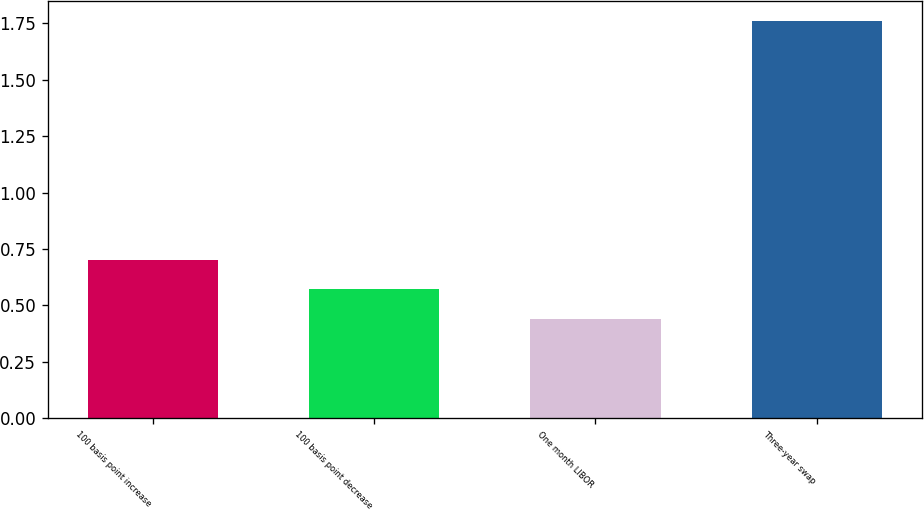Convert chart to OTSL. <chart><loc_0><loc_0><loc_500><loc_500><bar_chart><fcel>100 basis point increase<fcel>100 basis point decrease<fcel>One month LIBOR<fcel>Three-year swap<nl><fcel>0.7<fcel>0.57<fcel>0.44<fcel>1.76<nl></chart> 